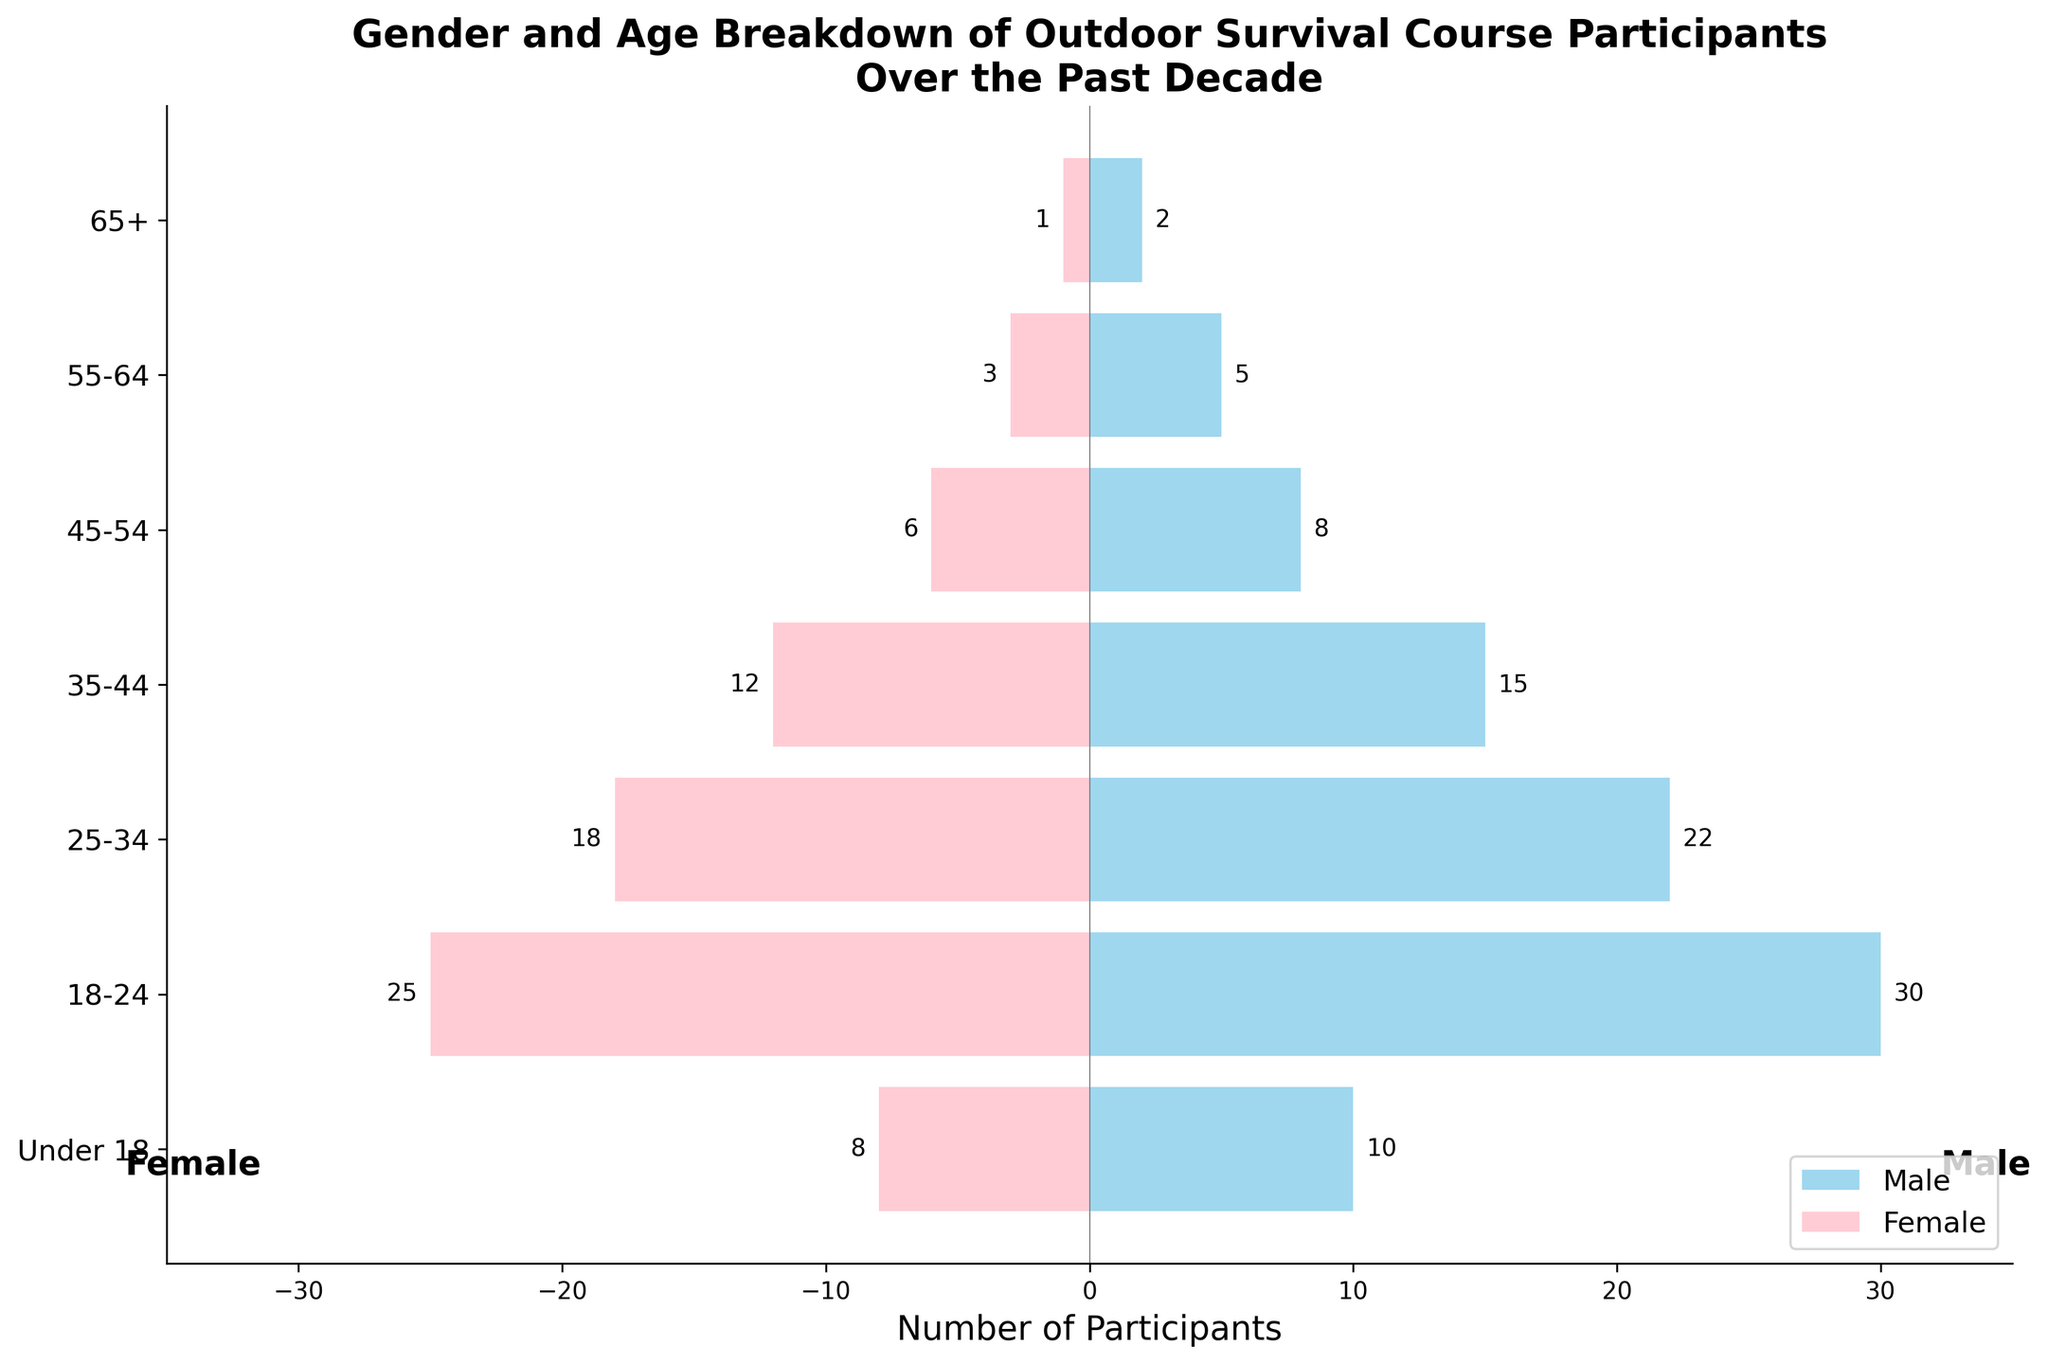What is the title of the plot? The title can be found at the top of the plot. It summarizes the main focus of the figure.
Answer: Gender and Age Breakdown of Outdoor Survival Course Participants Over the Past Decade What is the age group with the highest number of male participants? By examining the horizontal bars labeled 'Male', look for the longest bar to identify the age group with the highest number of male participants.
Answer: 18-24 How many more males than females participated in the 25-34 age group? For the 25-34 age group, note the number of males (22) and females (18). Subtract the number of females from the number of males.
Answer: 4 What is the total number of participants aged 65+? Sum the number of male participants (2) and female participants (1) in the 65+ age group.
Answer: 3 In which age group are the number of male and female participants closest to each other? Compare the differences between the number of male and female participants in each age group and find the smallest difference.
Answer: 35-44 How does the number of female participants in the 45-54 age group compare to those in the 18-24 age group? Compare the horizontal bars representing the number of female participants in both the 45-54 and 18-24 age groups.
Answer: Less What is the total number of participants under the age of 18? Add the number of male (10) and female (8) participants in the Under 18 age group.
Answer: 18 Which gender has more participants in the 55-64 age group? Compare the length of the horizontal bars for males and females in the 55-64 age group to determine which is longer.
Answer: Male How many participants aged 45-54 are there in total? Sum the number of male (8) and female (6) participants in the 45-54 age group.
Answer: 14 